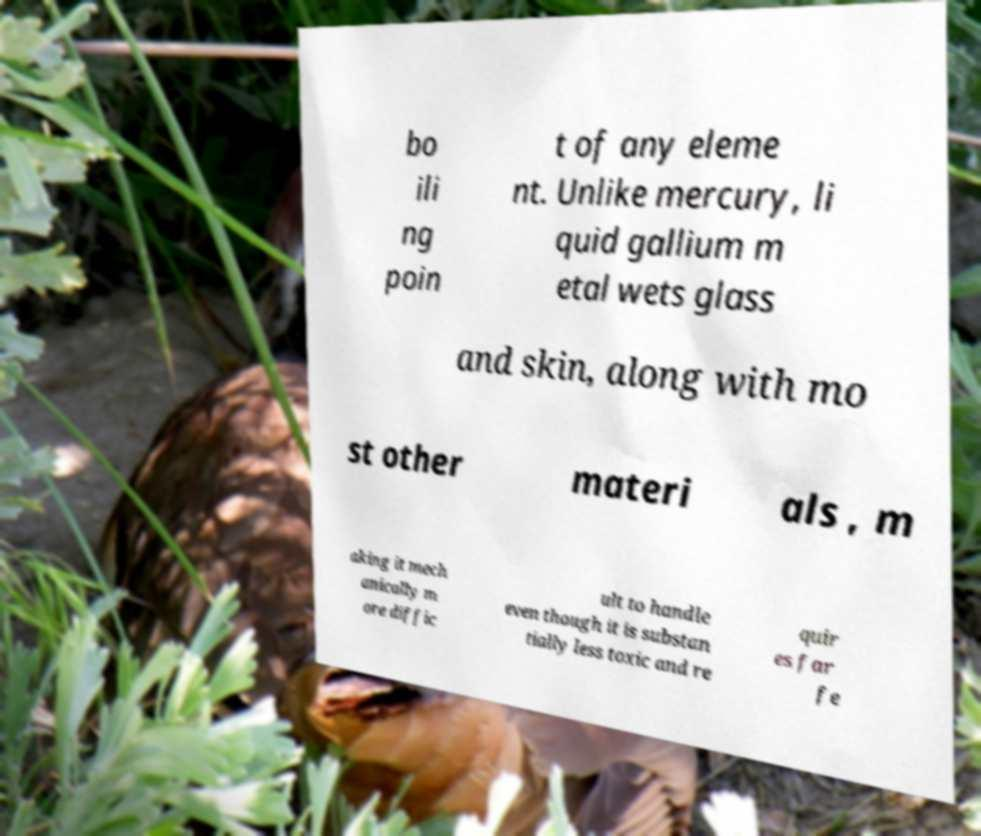Could you assist in decoding the text presented in this image and type it out clearly? bo ili ng poin t of any eleme nt. Unlike mercury, li quid gallium m etal wets glass and skin, along with mo st other materi als , m aking it mech anically m ore diffic ult to handle even though it is substan tially less toxic and re quir es far fe 